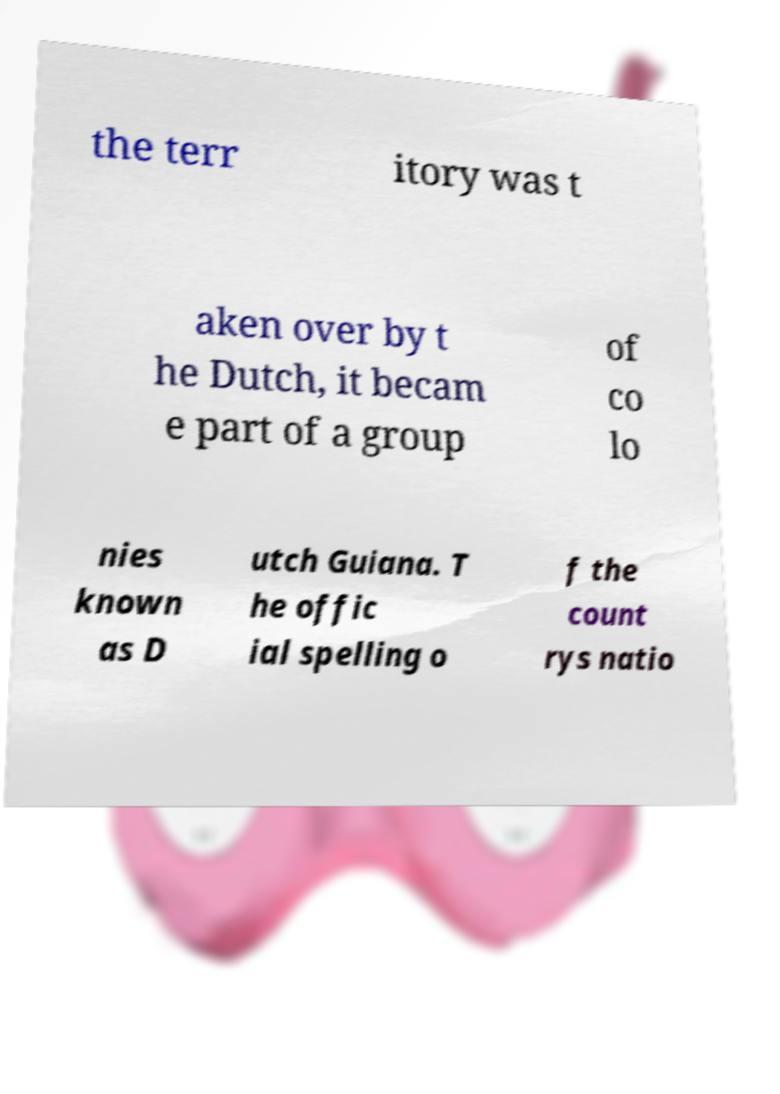Can you accurately transcribe the text from the provided image for me? the terr itory was t aken over by t he Dutch, it becam e part of a group of co lo nies known as D utch Guiana. T he offic ial spelling o f the count rys natio 